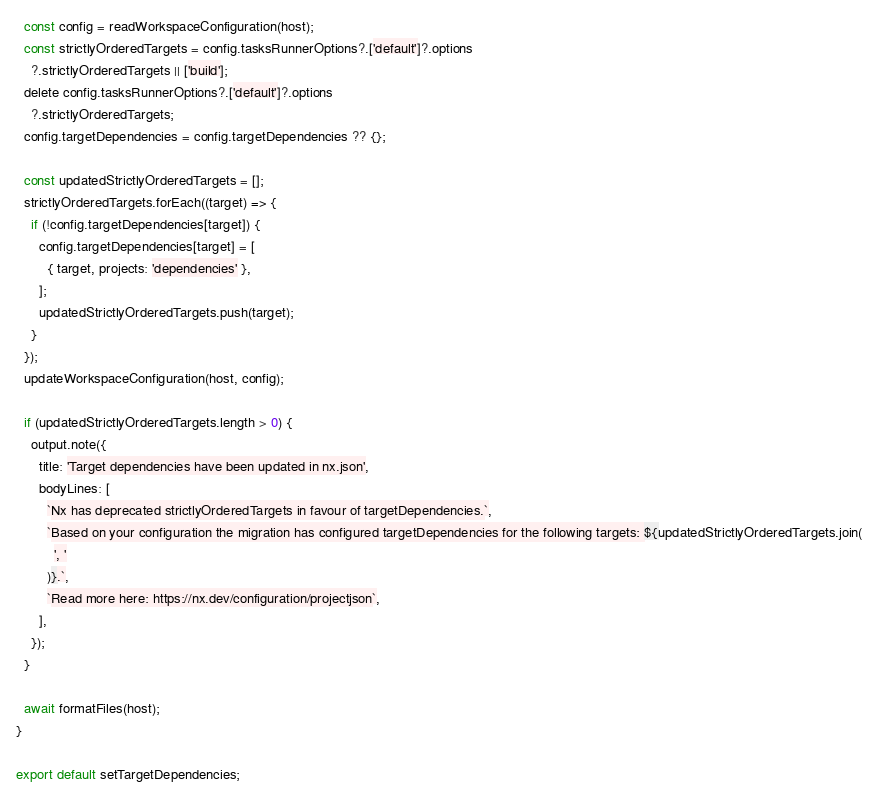<code> <loc_0><loc_0><loc_500><loc_500><_TypeScript_>  const config = readWorkspaceConfiguration(host);
  const strictlyOrderedTargets = config.tasksRunnerOptions?.['default']?.options
    ?.strictlyOrderedTargets || ['build'];
  delete config.tasksRunnerOptions?.['default']?.options
    ?.strictlyOrderedTargets;
  config.targetDependencies = config.targetDependencies ?? {};

  const updatedStrictlyOrderedTargets = [];
  strictlyOrderedTargets.forEach((target) => {
    if (!config.targetDependencies[target]) {
      config.targetDependencies[target] = [
        { target, projects: 'dependencies' },
      ];
      updatedStrictlyOrderedTargets.push(target);
    }
  });
  updateWorkspaceConfiguration(host, config);

  if (updatedStrictlyOrderedTargets.length > 0) {
    output.note({
      title: 'Target dependencies have been updated in nx.json',
      bodyLines: [
        `Nx has deprecated strictlyOrderedTargets in favour of targetDependencies.`,
        `Based on your configuration the migration has configured targetDependencies for the following targets: ${updatedStrictlyOrderedTargets.join(
          ', '
        )}.`,
        `Read more here: https://nx.dev/configuration/projectjson`,
      ],
    });
  }

  await formatFiles(host);
}

export default setTargetDependencies;
</code> 